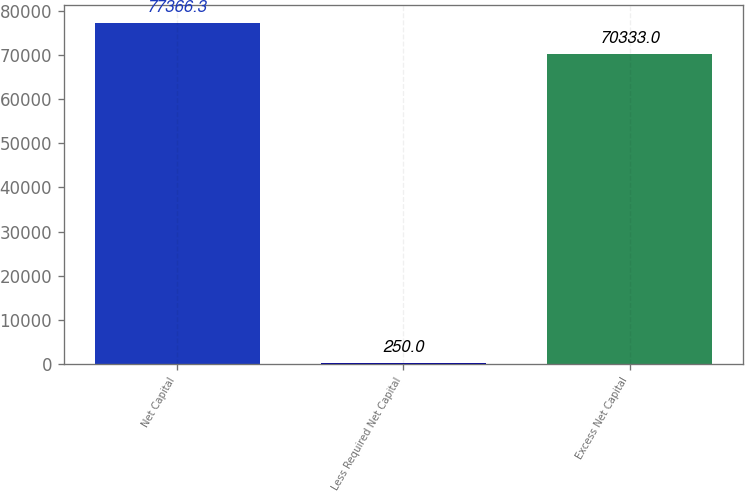Convert chart to OTSL. <chart><loc_0><loc_0><loc_500><loc_500><bar_chart><fcel>Net Capital<fcel>Less Required Net Capital<fcel>Excess Net Capital<nl><fcel>77366.3<fcel>250<fcel>70333<nl></chart> 